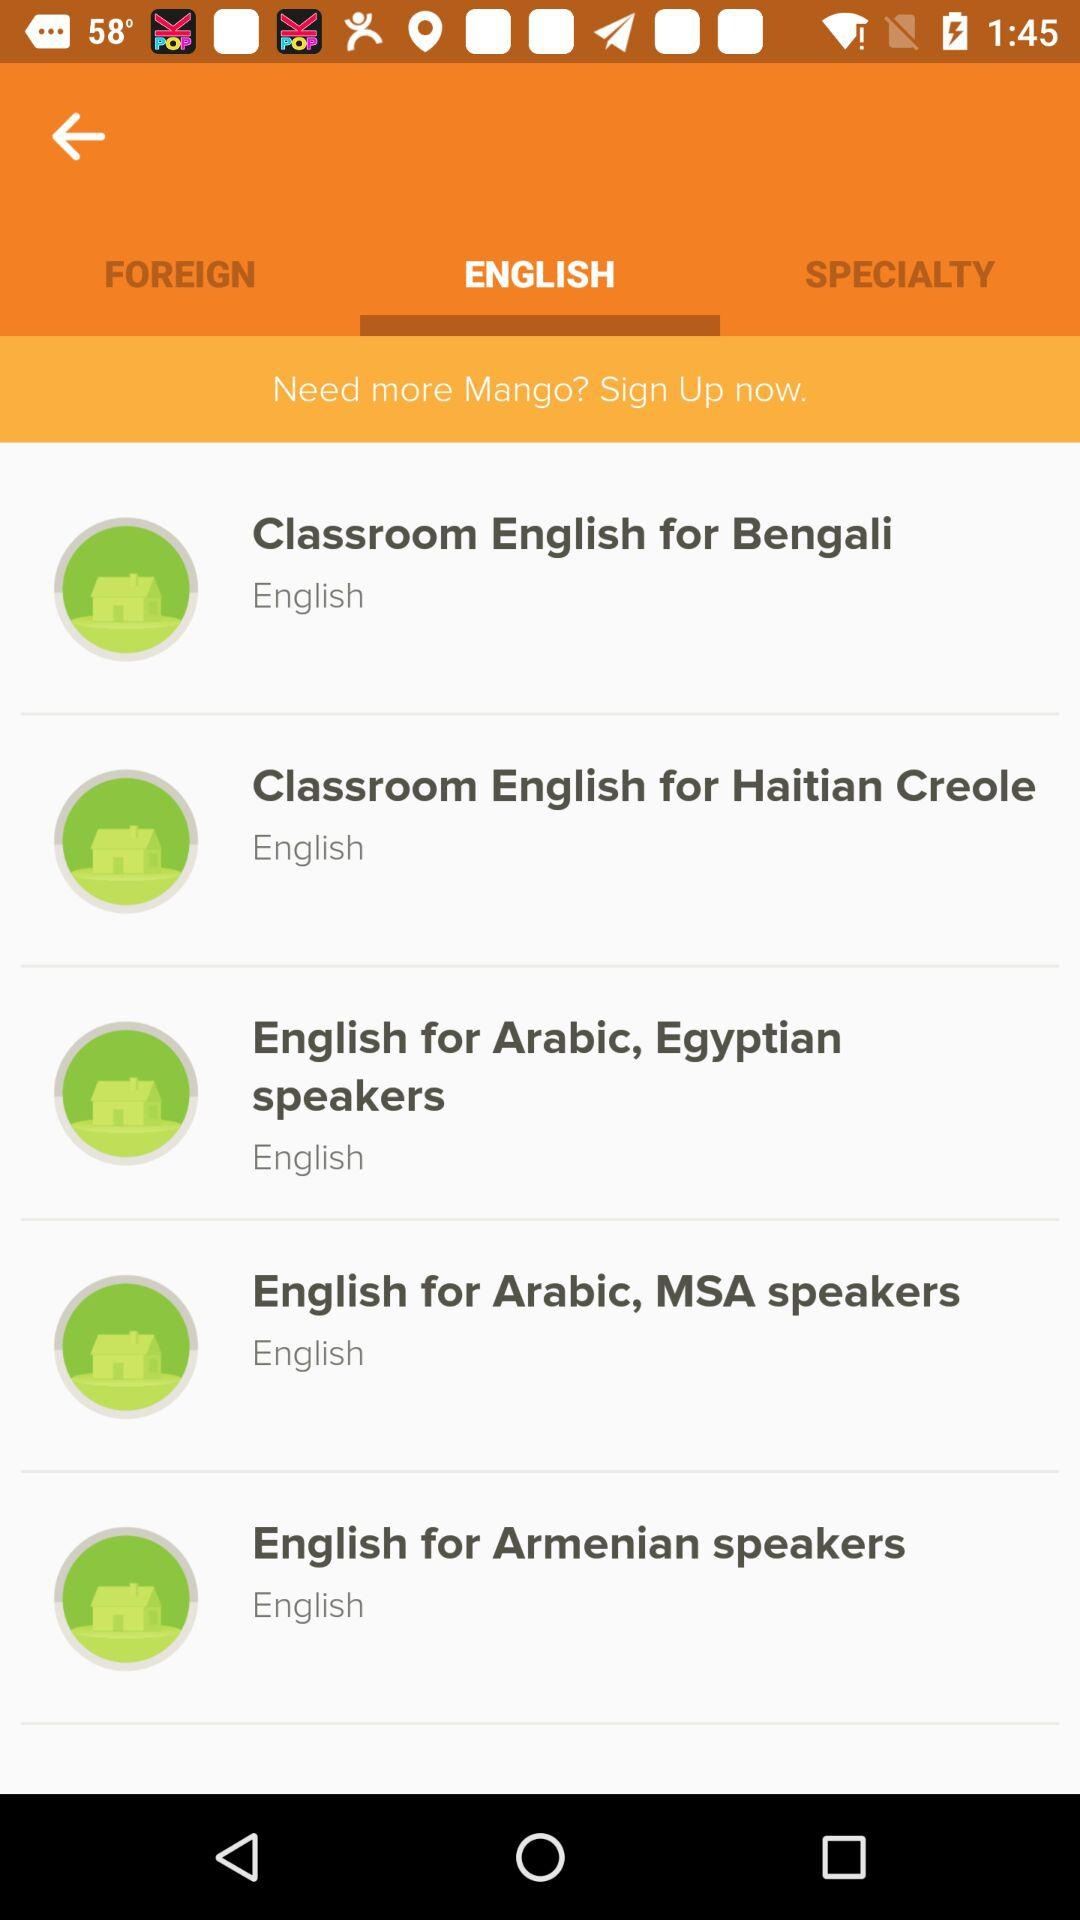How many Arabic language courses are there?
Answer the question using a single word or phrase. 2 